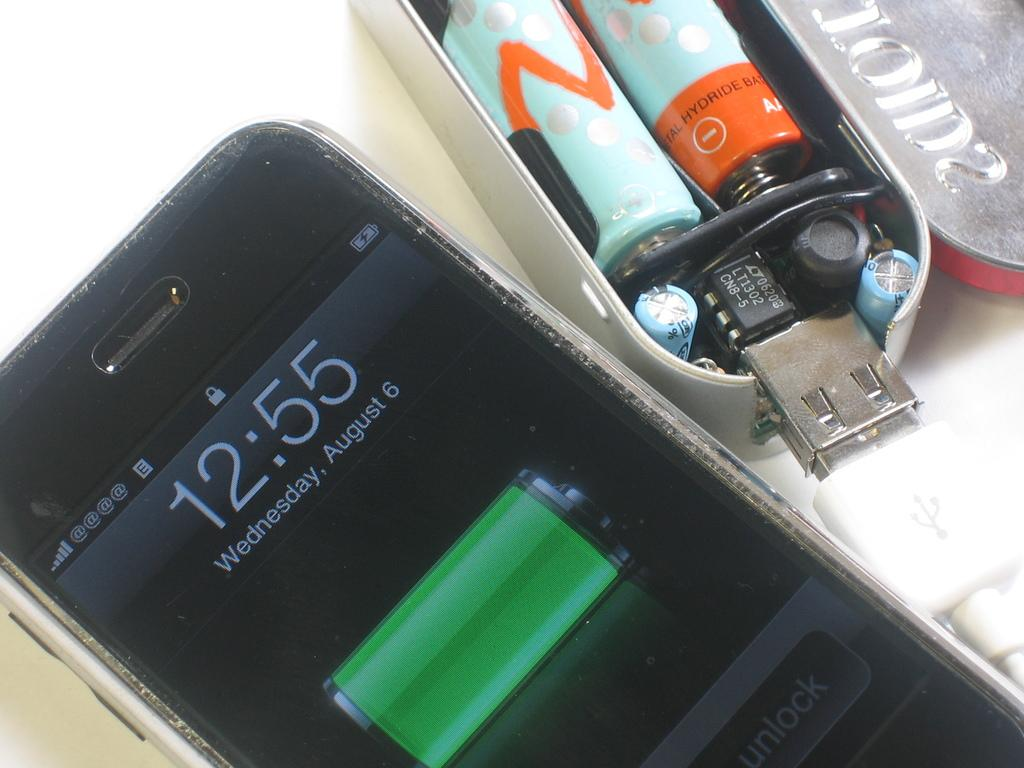<image>
Present a compact description of the photo's key features. cellphone charging on wednesday august 6 at 12:55 and a usb battery pack next to it 